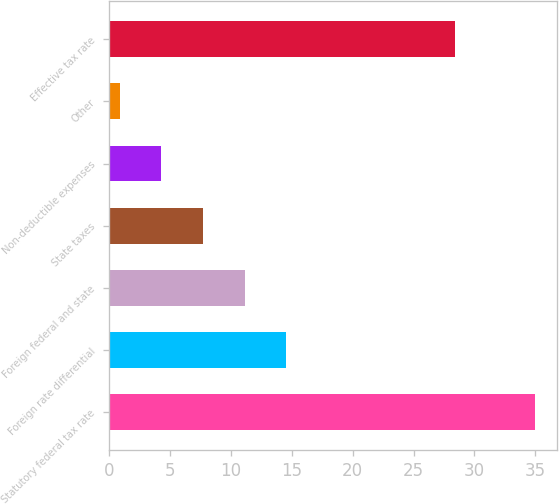<chart> <loc_0><loc_0><loc_500><loc_500><bar_chart><fcel>Statutory federal tax rate<fcel>Foreign rate differential<fcel>Foreign federal and state<fcel>State taxes<fcel>Non-deductible expenses<fcel>Other<fcel>Effective tax rate<nl><fcel>35<fcel>14.54<fcel>11.13<fcel>7.72<fcel>4.31<fcel>0.9<fcel>28.4<nl></chart> 